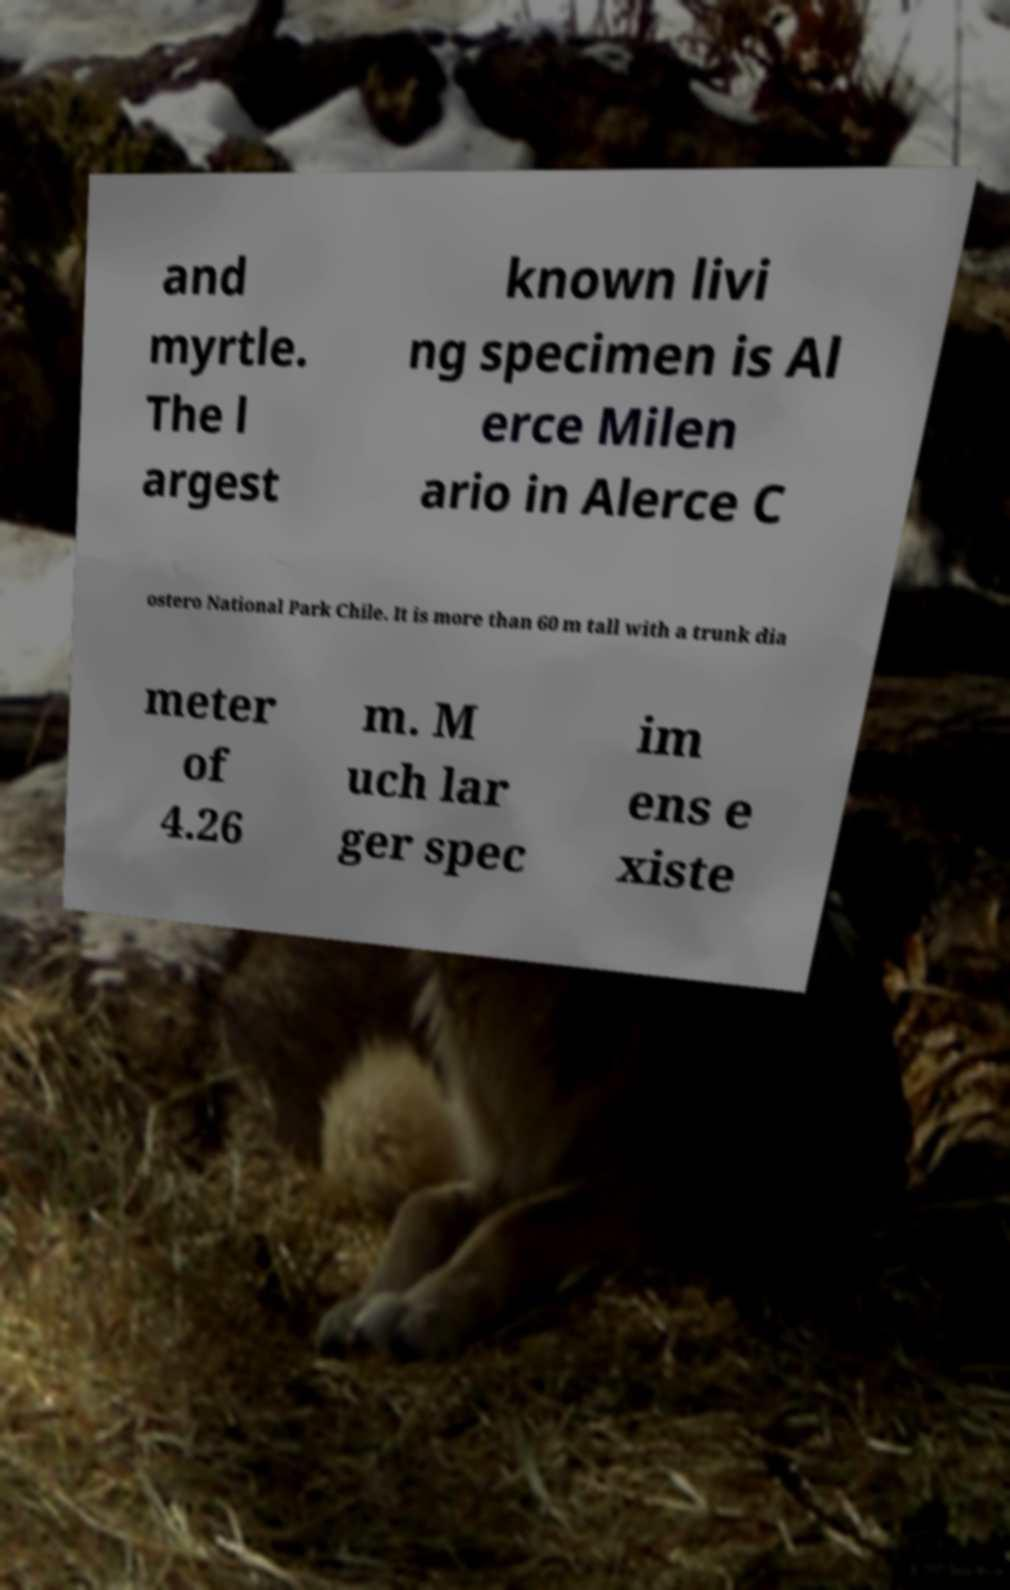What messages or text are displayed in this image? I need them in a readable, typed format. and myrtle. The l argest known livi ng specimen is Al erce Milen ario in Alerce C ostero National Park Chile. It is more than 60 m tall with a trunk dia meter of 4.26 m. M uch lar ger spec im ens e xiste 